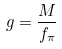Convert formula to latex. <formula><loc_0><loc_0><loc_500><loc_500>g = \frac { M } { f _ { \pi } }</formula> 